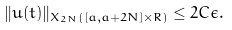Convert formula to latex. <formula><loc_0><loc_0><loc_500><loc_500>\| u ( t ) \| _ { X _ { 2 N } ( [ a , a + 2 N ] \times R ) } \leq 2 C \epsilon .</formula> 